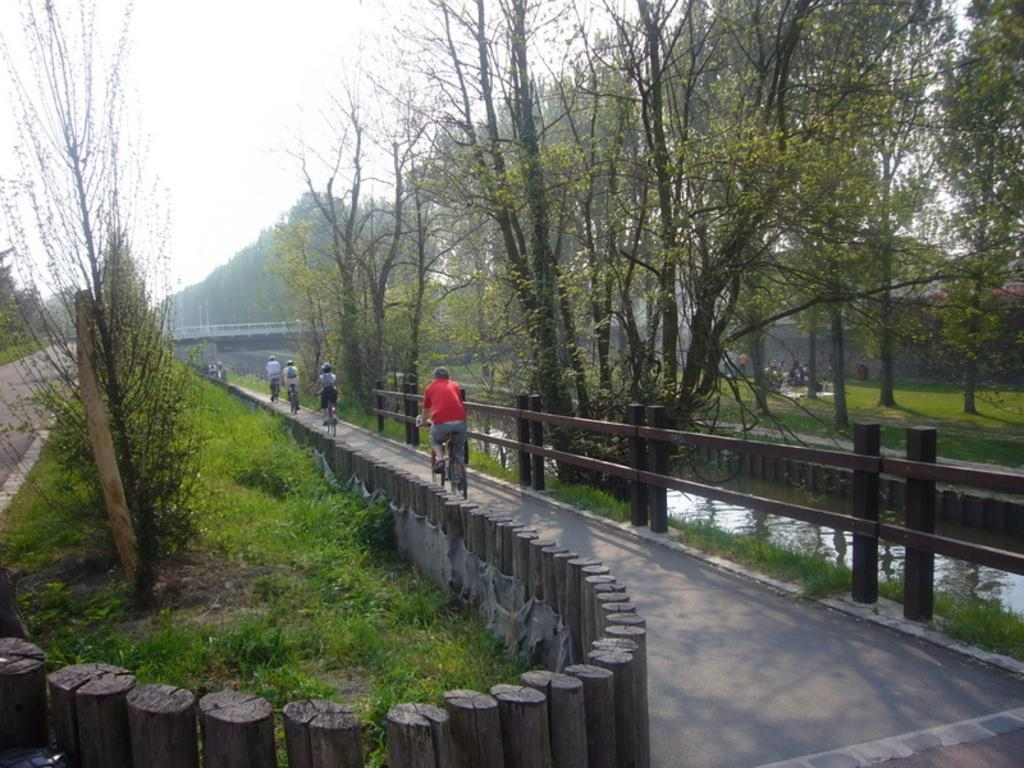What type of vegetation can be seen in the image? There is grass and trees in the image. What are the people in the image doing? The people in the image are riding bicycles. What else can be seen in the image besides the grass and trees? There is water visible in the image. What is visible at the top of the image? The sky is visible at the top of the image. Can you tell me how many vests are being worn by the people riding bicycles in the image? There is no information about vests being worn by the people in the image. What type of self-defense technique is being demonstrated by the trees in the image? There are no self-defense techniques being demonstrated by the trees in the image. 